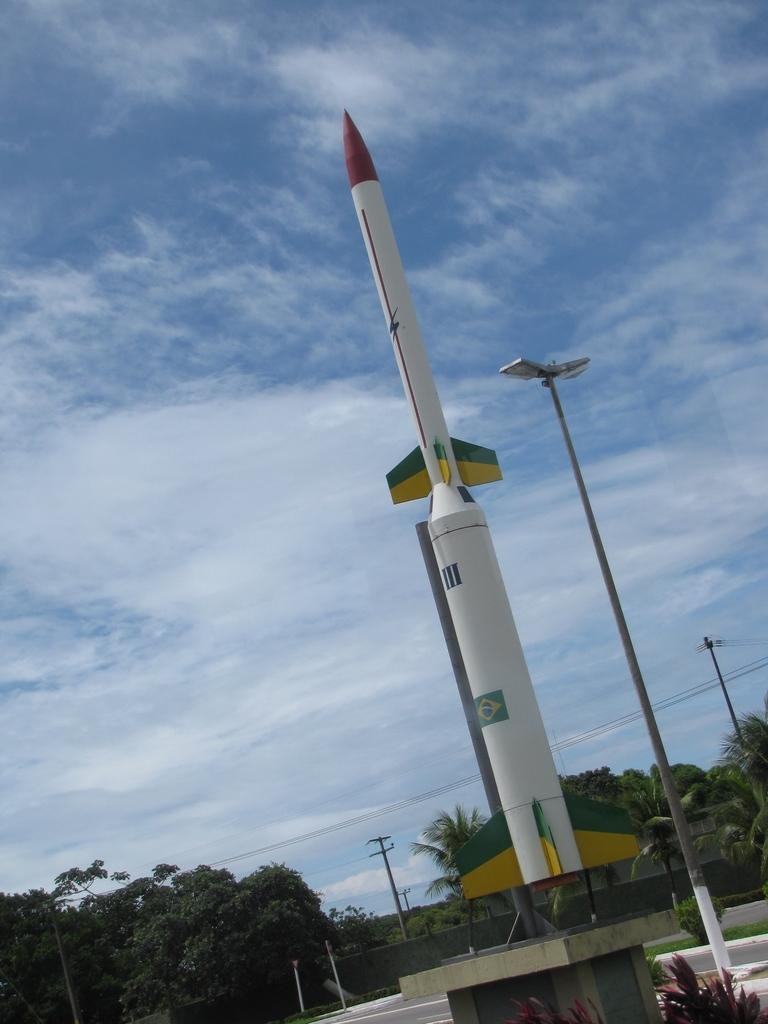What is the color of the rocket in the image? The rocket is white in the image. What is the status of the rocket in the image? The rocket is ready to launch. What can be seen beside the rocket? There are trees beside the rocket. What type of lighting is present in the image? There are street lights in the image. How would you describe the sky in the background? The sky is blue with clouds in the background. How much writing is visible on the rocket in the image? There is no writing visible on the rocket in the image. What stage of the rocket launch is depicted in the image? The image does not depict a specific stage of the rocket launch; it only shows the rocket ready to launch. 